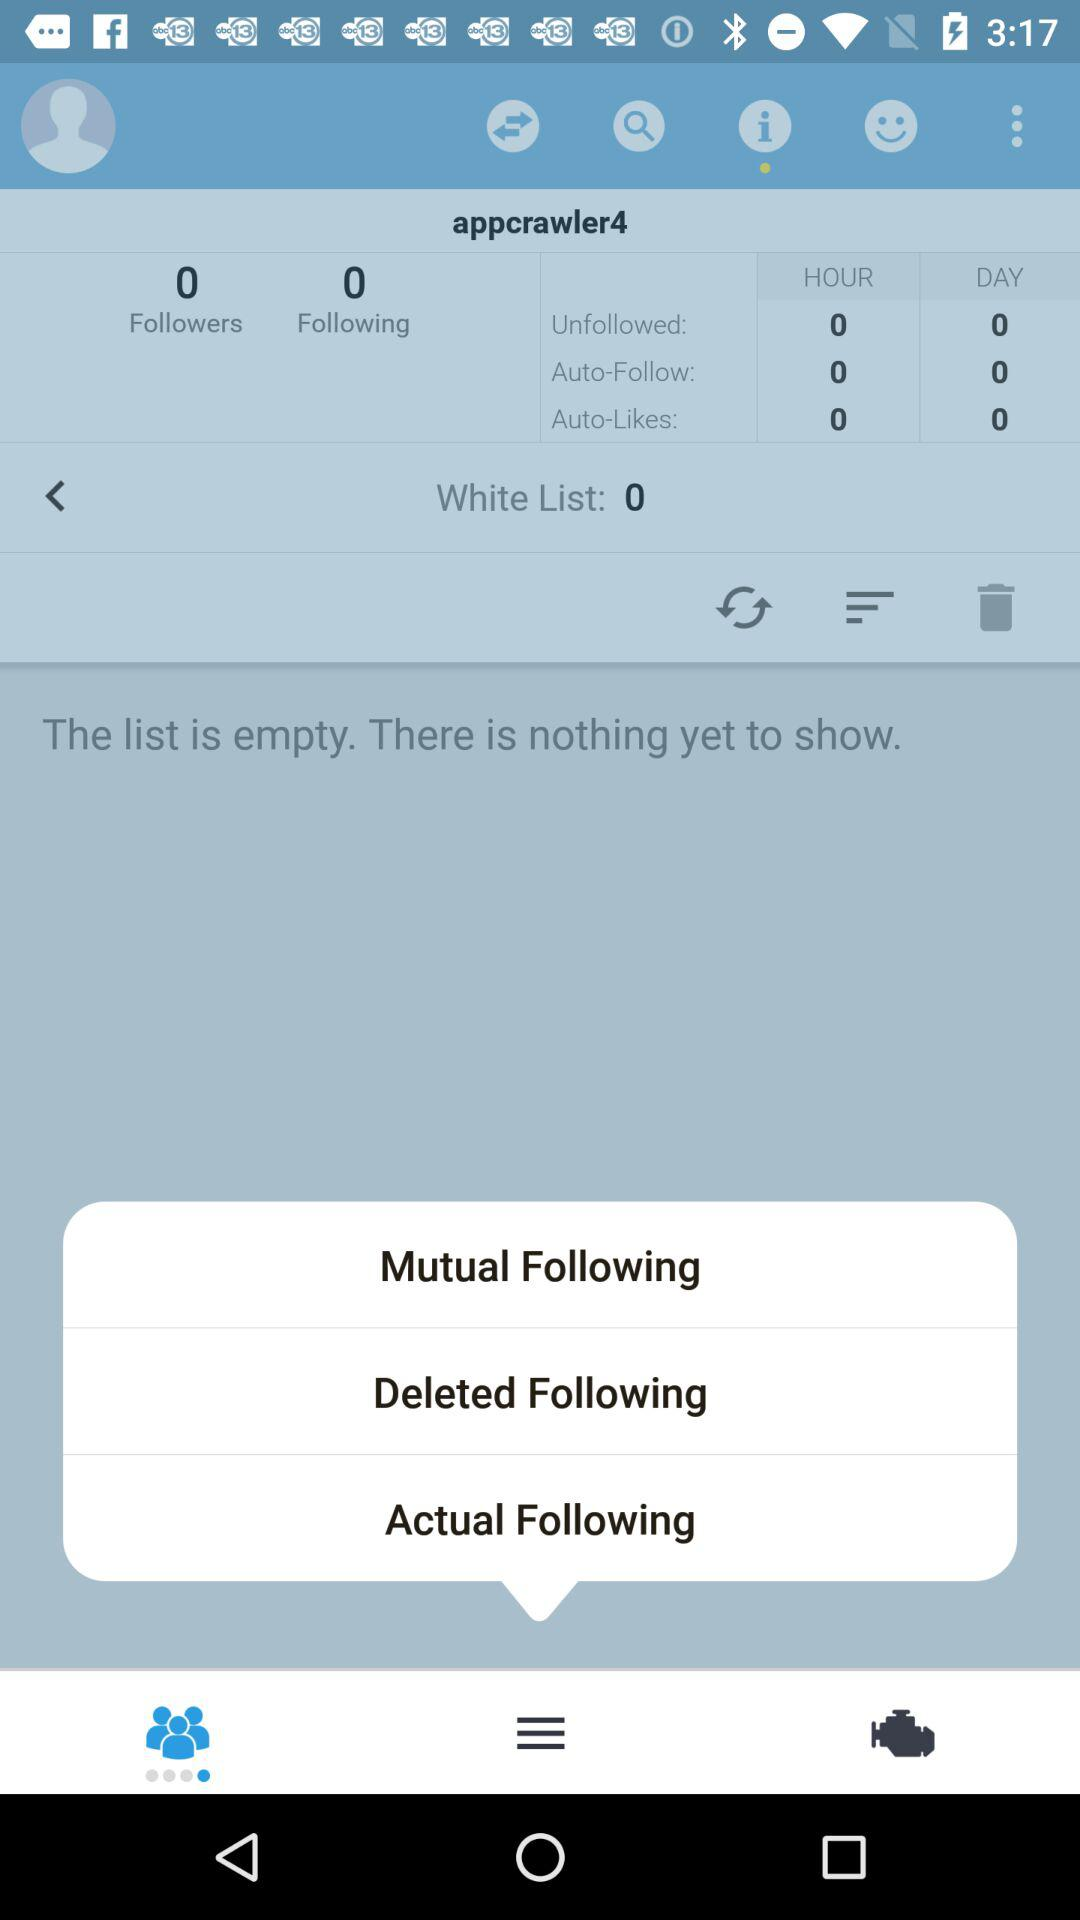How many followers are there? There are 0 followers. 